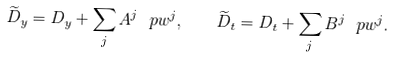<formula> <loc_0><loc_0><loc_500><loc_500>\widetilde { D } _ { y } = D _ { y } + \sum _ { j } A ^ { j } \ p { w ^ { j } } , \quad \widetilde { D } _ { t } = D _ { t } + \sum _ { j } B ^ { j } \ p { w ^ { j } } .</formula> 